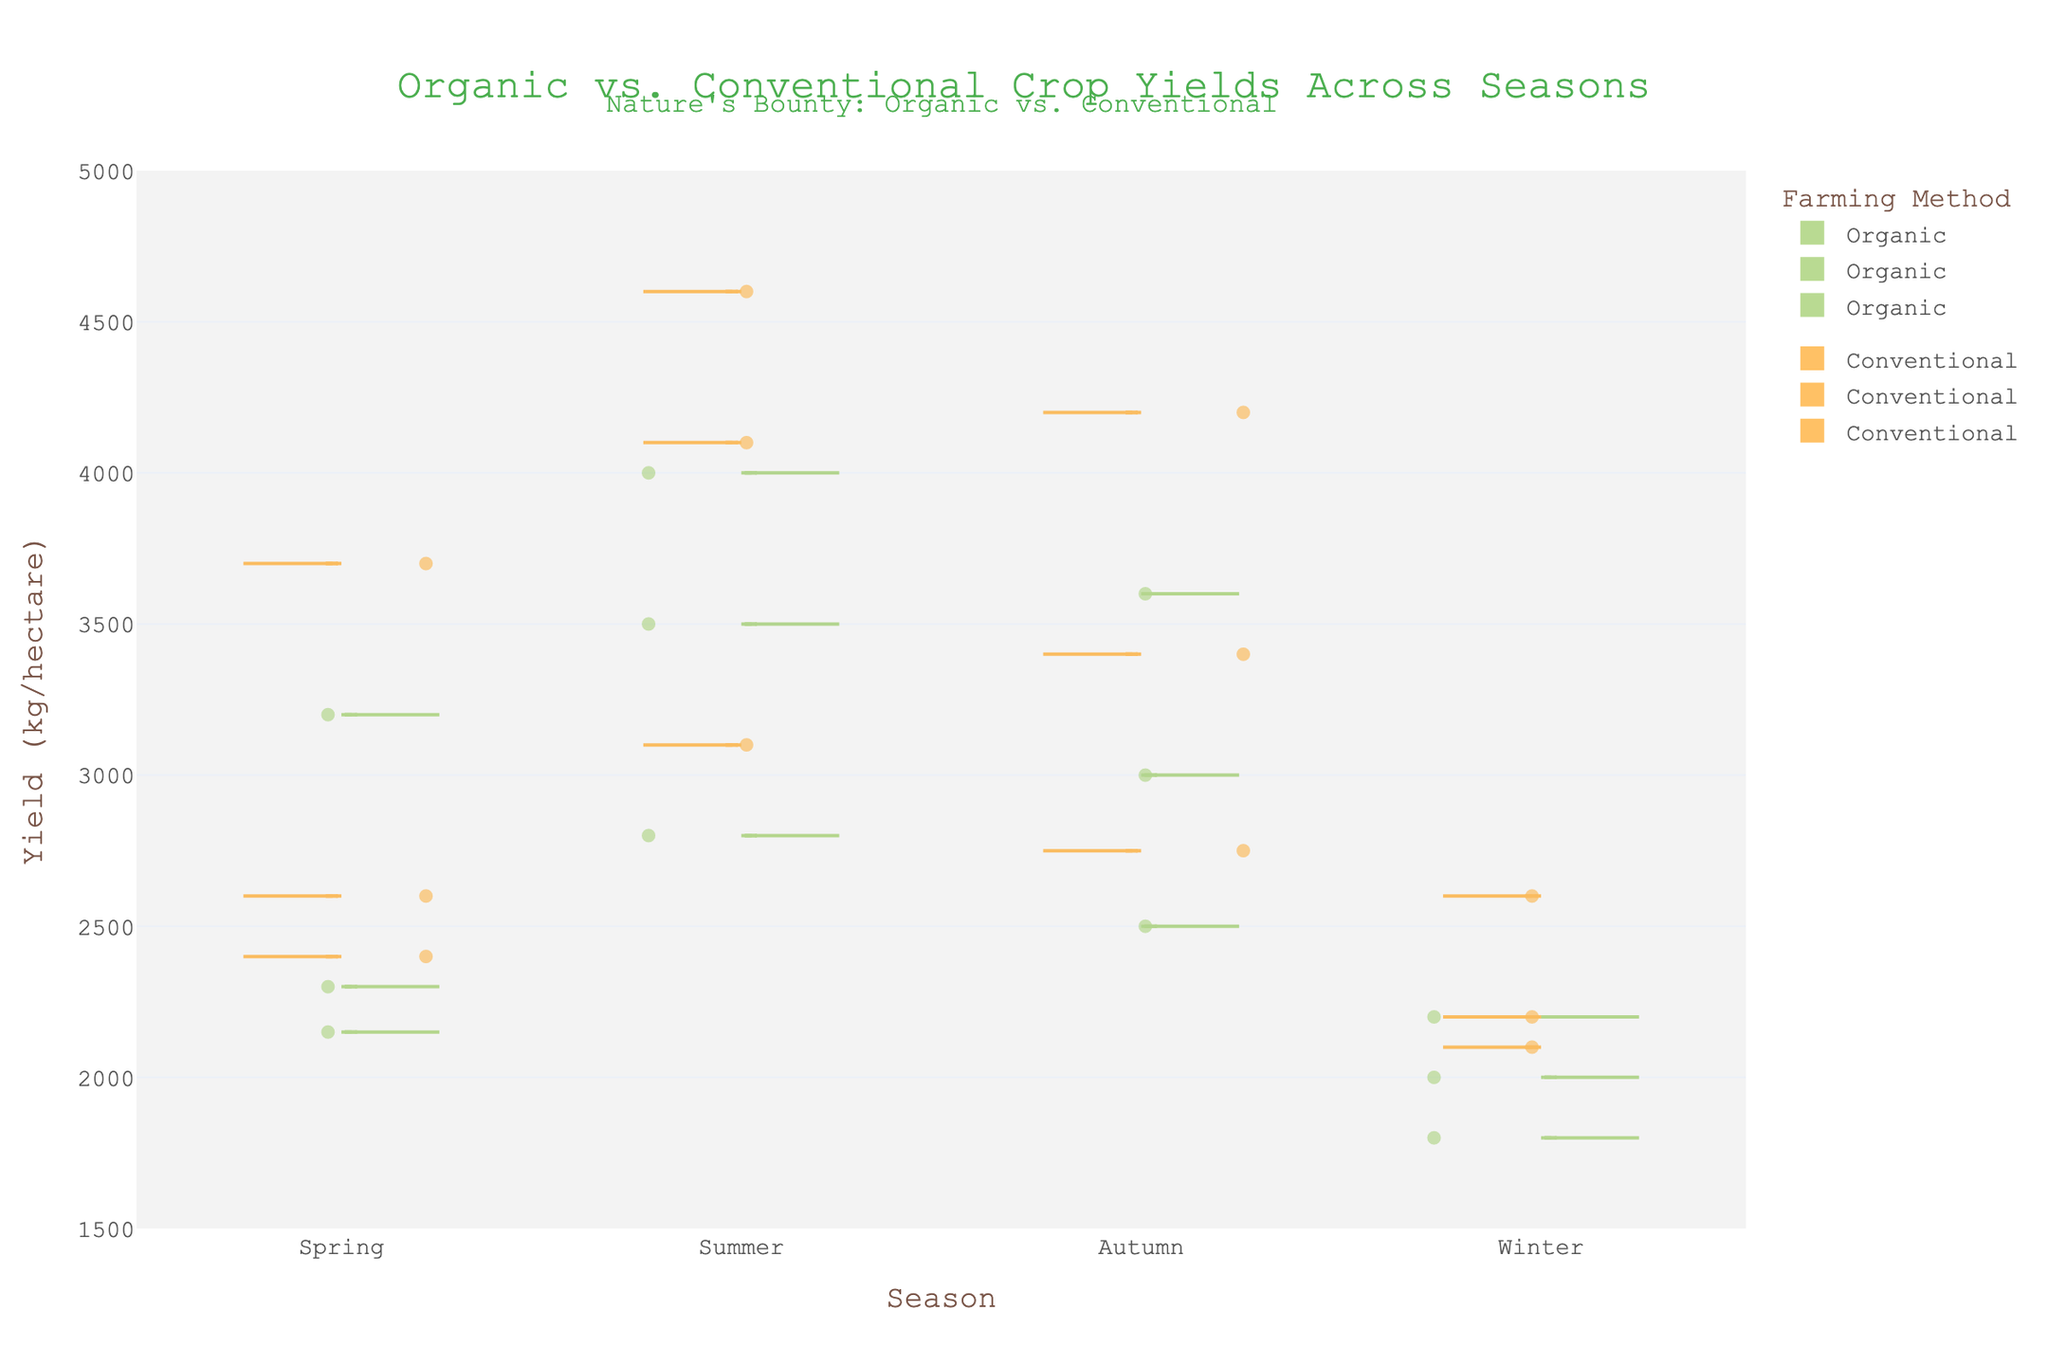What is the title of the chart? The title of the chart is written at the top and reads "Organic vs. Conventional Crop Yields Across Seasons."
Answer: Organic vs. Conventional Crop Yields Across Seasons Which season has the highest average yield for conventional crops? By examining the positions of the points and the density of the violins for conventional crops, summer seems to have the highest yield since its values are higher compared to other seasons.
Answer: Summer What is the color used to represent organic crops? The color for organic crops is a shade of green, which can be observed on the left (positive side) of the violins.
Answer: Green How does the median yield of organic carrots in spring compare to that in autumn? Examining the median lines in the violins for organic carrot yields in spring and autumn reveals that the yield is slightly higher in spring than in autumn.
Answer: Higher in spring Which crop and season combination has the lowest yield for organic farming? By looking at all the organic data points across seasons, winter tomatoes have the lowest yield evident from the lowest position of their violin plot.
Answer: Winter tomatoes What can be said about the variability in the yields of conventional corn across seasons? The width of the violin plots indicates the variability. Conventional corn has a higher variability in summer and autumn, as suggested by the wider violin plot segments in these seasons.
Answer: Higher variability in summer and autumn Between organic and conventional tomatoes in summer, which has a greater yield? Comparing the positions of the medians and the general distribution of yields, conventional tomatoes in summer have a greater yield than organic tomatoes.
Answer: Conventional tomatoes What kind of relationship can be observed in crop yields between organic and conventional farming methods across different seasons? Across all seasons, conventional farming methods tend to produce higher yields for all crops compared to organic methods, as denoted by the consistently higher positions of conventional violin plots relative to organic ones.
Answer: Conventional farming produces higher yields How do the yields of organic carrots fluctuate across different seasons? The yields of organic carrots vary across seasons, appearing lowest in winter, rising in spring, peaking in summer, and then slightly decreasing in autumn based on the position of the violin plots.
Answer: Varies: lowest in winter, rising in spring, peaking in summer, decreasing in autumn What is the average yield of organic corn in spring and autumn? Spring: 3200 kg/hectare, Autumn: 3600 kg/hectare. Average: (3200 + 3600) / 2 = 3400 kg/hectare.
Answer: 3400 kg/hectare 